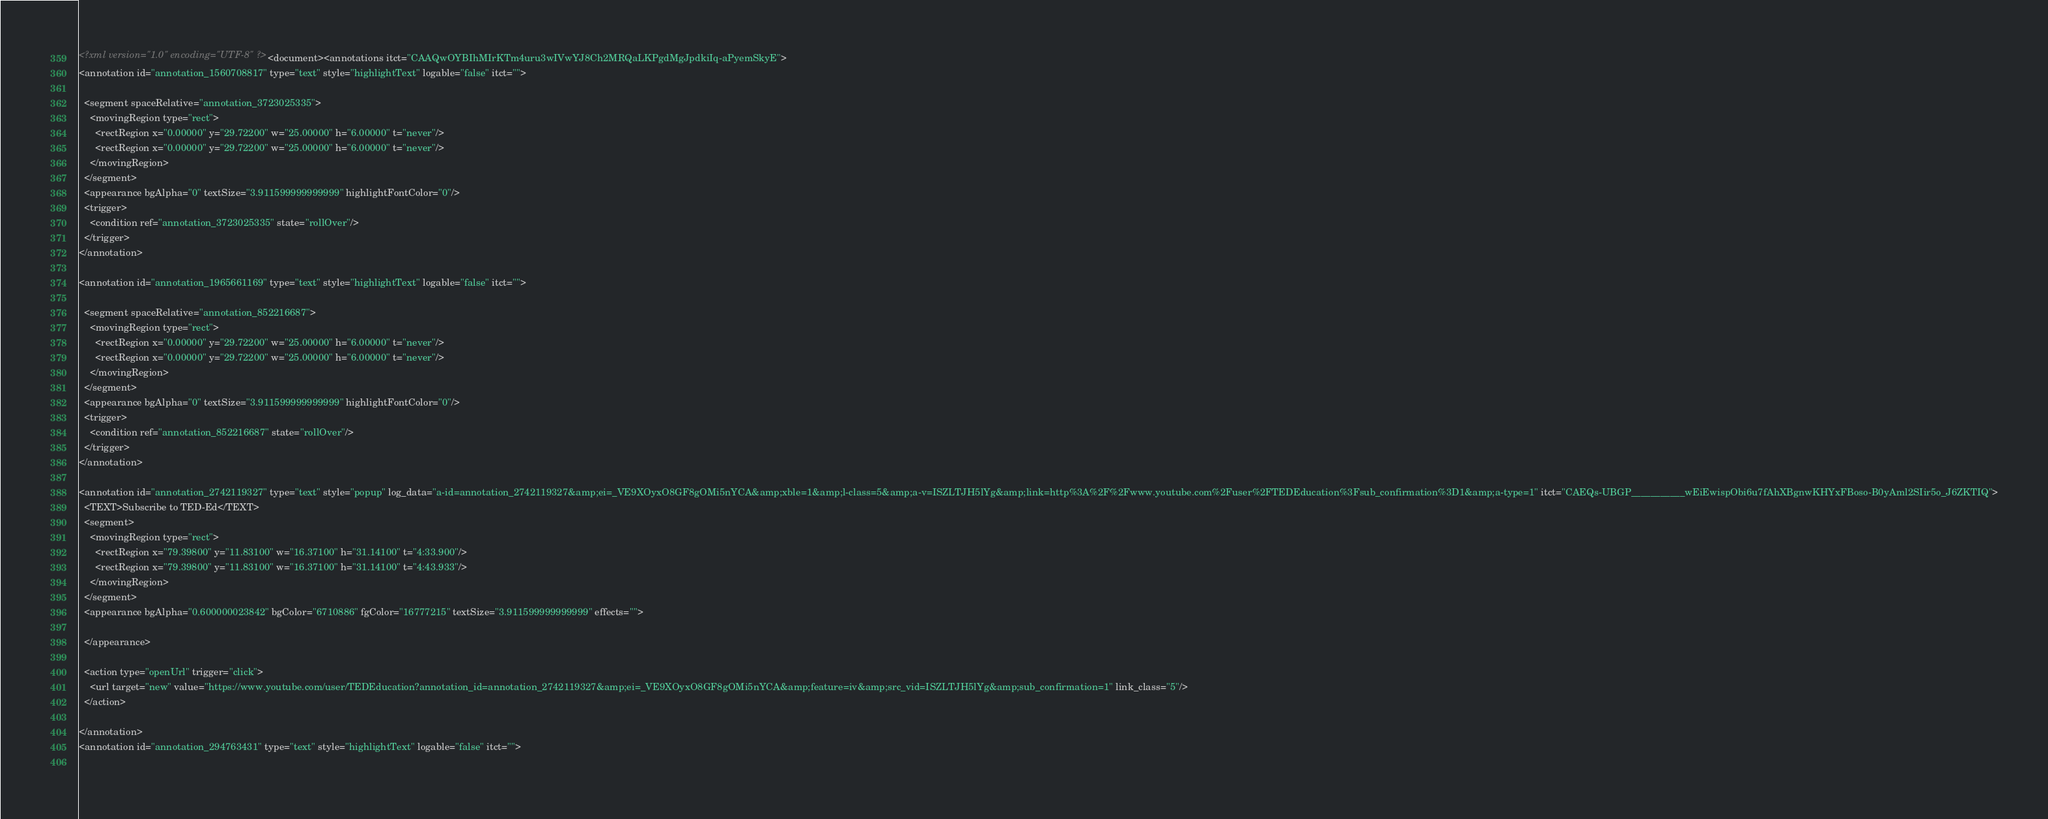<code> <loc_0><loc_0><loc_500><loc_500><_XML_><?xml version="1.0" encoding="UTF-8" ?><document><annotations itct="CAAQwOYBIhMIrKTm4uru3wIVwYJ8Ch2MRQaLKPgdMgJpdkiIq-aPyemSkyE">
<annotation id="annotation_1560708817" type="text" style="highlightText" logable="false" itct="">
  
  <segment spaceRelative="annotation_3723025335">
    <movingRegion type="rect">
      <rectRegion x="0.00000" y="29.72200" w="25.00000" h="6.00000" t="never"/>
      <rectRegion x="0.00000" y="29.72200" w="25.00000" h="6.00000" t="never"/>
    </movingRegion>
  </segment>
  <appearance bgAlpha="0" textSize="3.911599999999999" highlightFontColor="0"/>
  <trigger>
    <condition ref="annotation_3723025335" state="rollOver"/>
  </trigger>
</annotation>

<annotation id="annotation_1965661169" type="text" style="highlightText" logable="false" itct="">
  
  <segment spaceRelative="annotation_852216687">
    <movingRegion type="rect">
      <rectRegion x="0.00000" y="29.72200" w="25.00000" h="6.00000" t="never"/>
      <rectRegion x="0.00000" y="29.72200" w="25.00000" h="6.00000" t="never"/>
    </movingRegion>
  </segment>
  <appearance bgAlpha="0" textSize="3.911599999999999" highlightFontColor="0"/>
  <trigger>
    <condition ref="annotation_852216687" state="rollOver"/>
  </trigger>
</annotation>

<annotation id="annotation_2742119327" type="text" style="popup" log_data="a-id=annotation_2742119327&amp;ei=_VE9XOyxO8GF8gOMi5nYCA&amp;xble=1&amp;l-class=5&amp;a-v=ISZLTJH5lYg&amp;link=http%3A%2F%2Fwww.youtube.com%2Fuser%2FTEDEducation%3Fsub_confirmation%3D1&amp;a-type=1" itct="CAEQs-UBGP___________wEiEwispObi6u7fAhXBgnwKHYxFBoso-B0yAml2SIir5o_J6ZKTIQ">
  <TEXT>Subscribe to TED-Ed</TEXT>
  <segment>
    <movingRegion type="rect">
      <rectRegion x="79.39800" y="11.83100" w="16.37100" h="31.14100" t="4:33.900"/>
      <rectRegion x="79.39800" y="11.83100" w="16.37100" h="31.14100" t="4:43.933"/>
    </movingRegion>
  </segment>
  <appearance bgAlpha="0.600000023842" bgColor="6710886" fgColor="16777215" textSize="3.911599999999999" effects="">
    
  </appearance>
  
  <action type="openUrl" trigger="click">
    <url target="new" value="https://www.youtube.com/user/TEDEducation?annotation_id=annotation_2742119327&amp;ei=_VE9XOyxO8GF8gOMi5nYCA&amp;feature=iv&amp;src_vid=ISZLTJH5lYg&amp;sub_confirmation=1" link_class="5"/>
  </action>

</annotation>
<annotation id="annotation_294763431" type="text" style="highlightText" logable="false" itct="">
  </code> 